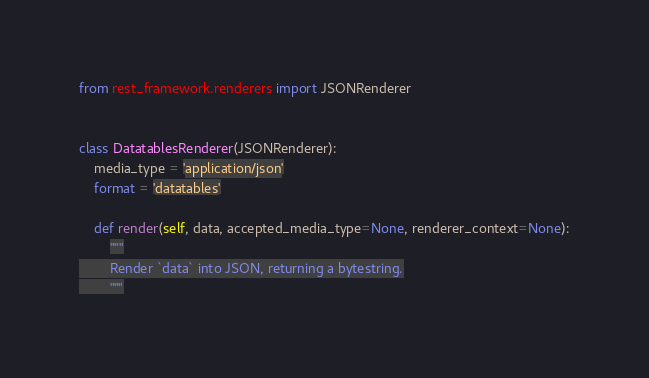<code> <loc_0><loc_0><loc_500><loc_500><_Python_>from rest_framework.renderers import JSONRenderer


class DatatablesRenderer(JSONRenderer):
    media_type = 'application/json'
    format = 'datatables'

    def render(self, data, accepted_media_type=None, renderer_context=None):
        """
        Render `data` into JSON, returning a bytestring.
        """</code> 